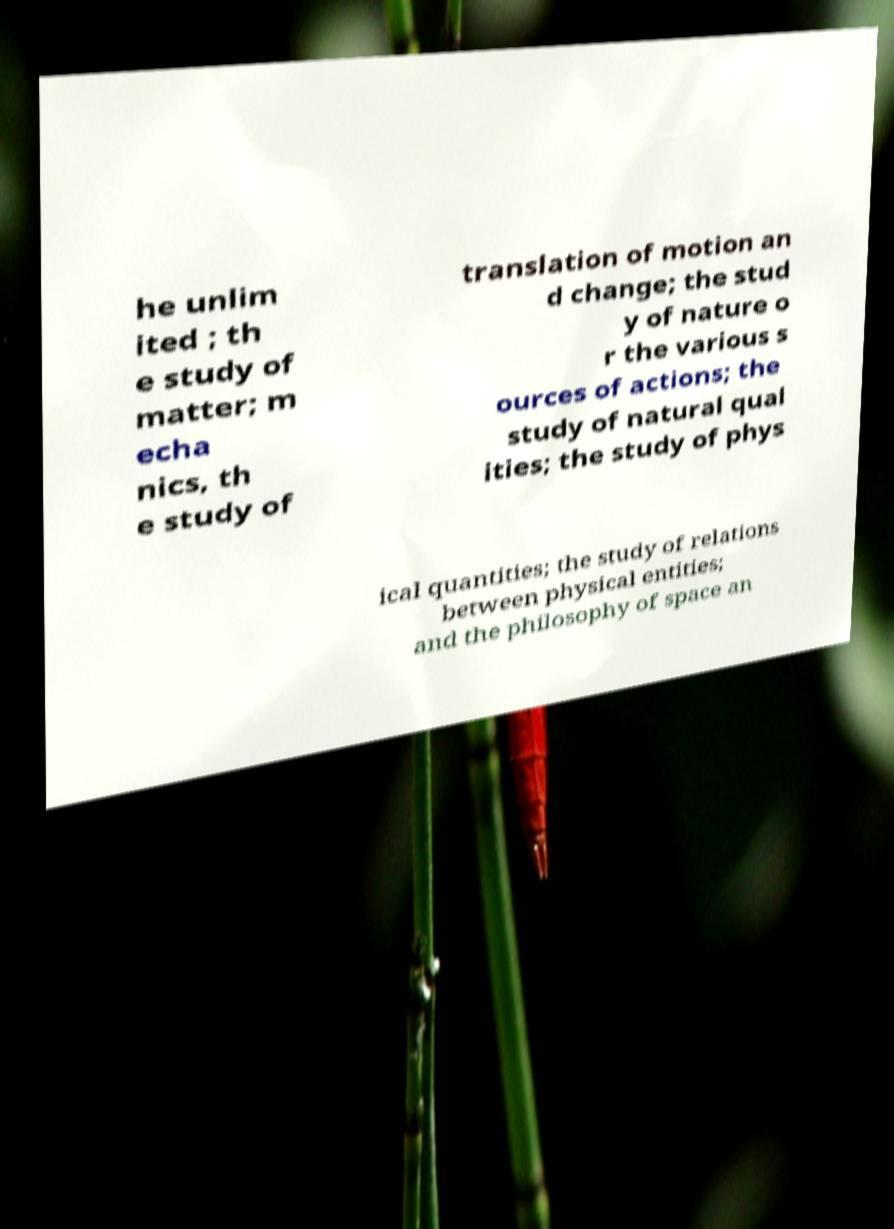Could you assist in decoding the text presented in this image and type it out clearly? he unlim ited ; th e study of matter; m echa nics, th e study of translation of motion an d change; the stud y of nature o r the various s ources of actions; the study of natural qual ities; the study of phys ical quantities; the study of relations between physical entities; and the philosophy of space an 